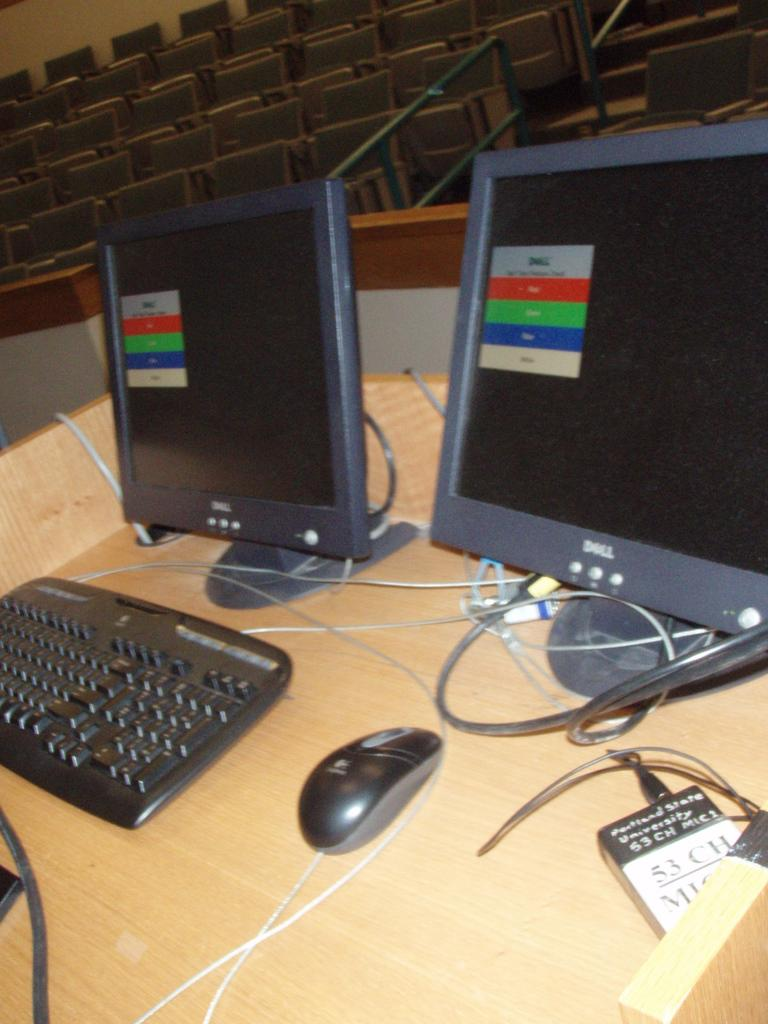<image>
Share a concise interpretation of the image provided. two monitors sit on the desk of a professor at portland state university 